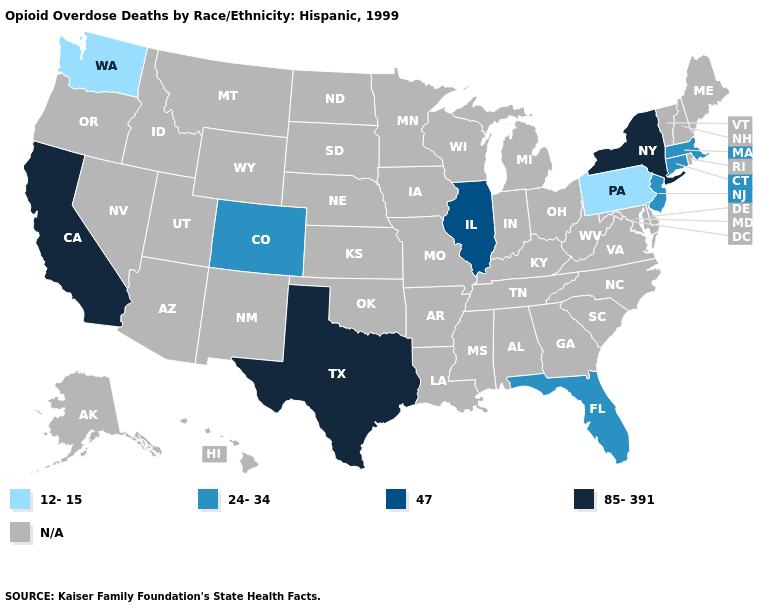What is the lowest value in the Northeast?
Be succinct. 12-15. Is the legend a continuous bar?
Answer briefly. No. What is the value of Vermont?
Quick response, please. N/A. What is the value of Wisconsin?
Answer briefly. N/A. Which states have the highest value in the USA?
Write a very short answer. California, New York, Texas. Is the legend a continuous bar?
Be succinct. No. Name the states that have a value in the range 12-15?
Answer briefly. Pennsylvania, Washington. Does Washington have the lowest value in the USA?
Short answer required. Yes. Which states hav the highest value in the South?
Keep it brief. Texas. Which states have the lowest value in the USA?
Short answer required. Pennsylvania, Washington. What is the value of Minnesota?
Concise answer only. N/A. Name the states that have a value in the range N/A?
Concise answer only. Alabama, Alaska, Arizona, Arkansas, Delaware, Georgia, Hawaii, Idaho, Indiana, Iowa, Kansas, Kentucky, Louisiana, Maine, Maryland, Michigan, Minnesota, Mississippi, Missouri, Montana, Nebraska, Nevada, New Hampshire, New Mexico, North Carolina, North Dakota, Ohio, Oklahoma, Oregon, Rhode Island, South Carolina, South Dakota, Tennessee, Utah, Vermont, Virginia, West Virginia, Wisconsin, Wyoming. 